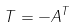Convert formula to latex. <formula><loc_0><loc_0><loc_500><loc_500>T = - A ^ { T }</formula> 